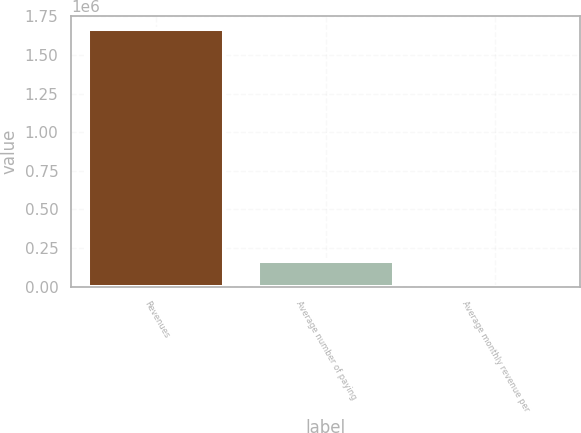Convert chart. <chart><loc_0><loc_0><loc_500><loc_500><bar_chart><fcel>Revenues<fcel>Average number of paying<fcel>Average monthly revenue per<nl><fcel>1.67027e+06<fcel>167039<fcel>13.3<nl></chart> 